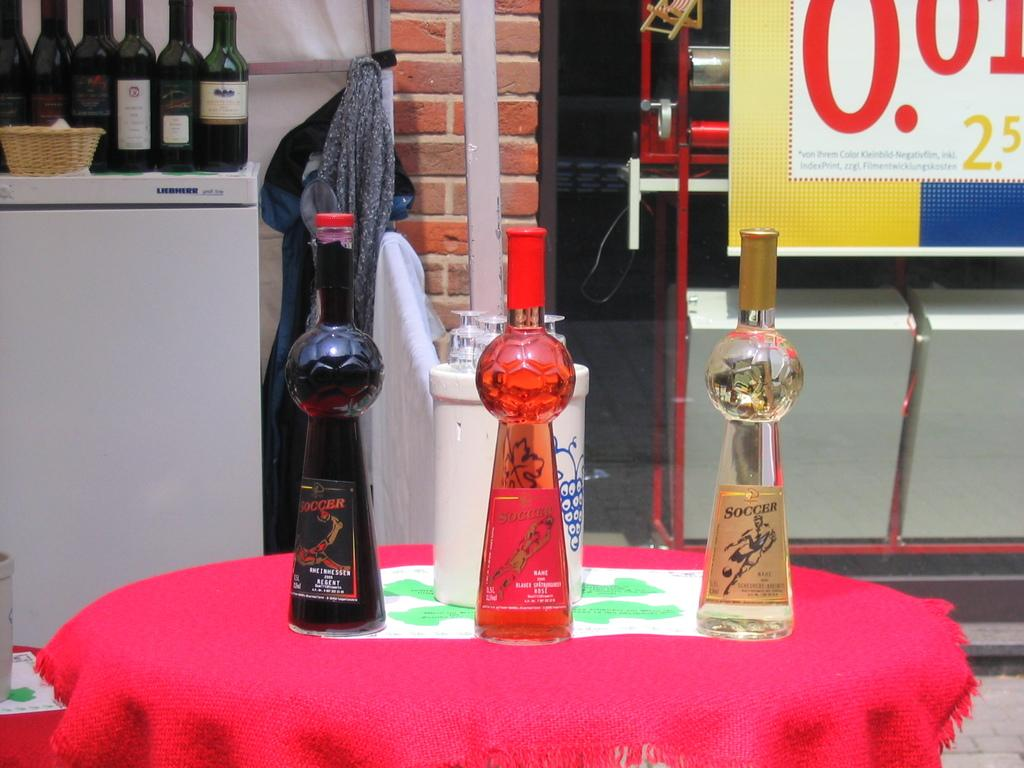What can be found on the refrigerator in the image? There are bottles on the refrigerator in the image. What is present in the image besides the refrigerator? There is a basket and a cloth in the image. What is the color of the cloth in the image? There is a red cloth in the image. What is on the table in the image? There are objects and glasses on the table in the image. Can you see any fruit jumping in the image? There is no fruit or jumping depicted in the image. What type of show is being performed on the table in the image? There is no show being performed in the image; it features objects and glasses on the table. 